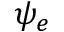Convert formula to latex. <formula><loc_0><loc_0><loc_500><loc_500>\psi _ { e }</formula> 